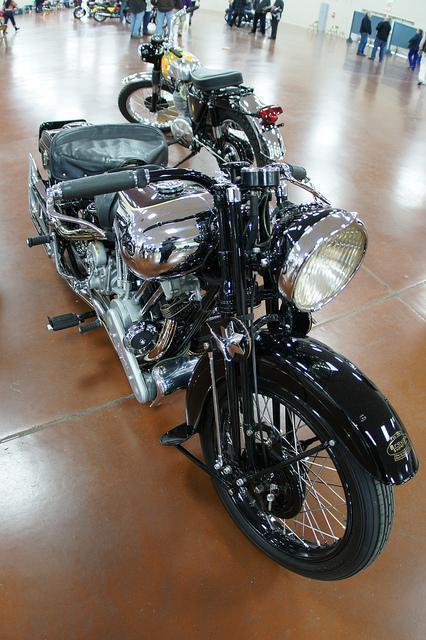What is the large glass object on the bike called?
Select the accurate response from the four choices given to answer the question.
Options: Headlight, turn light, break light, night light. Headlight. 